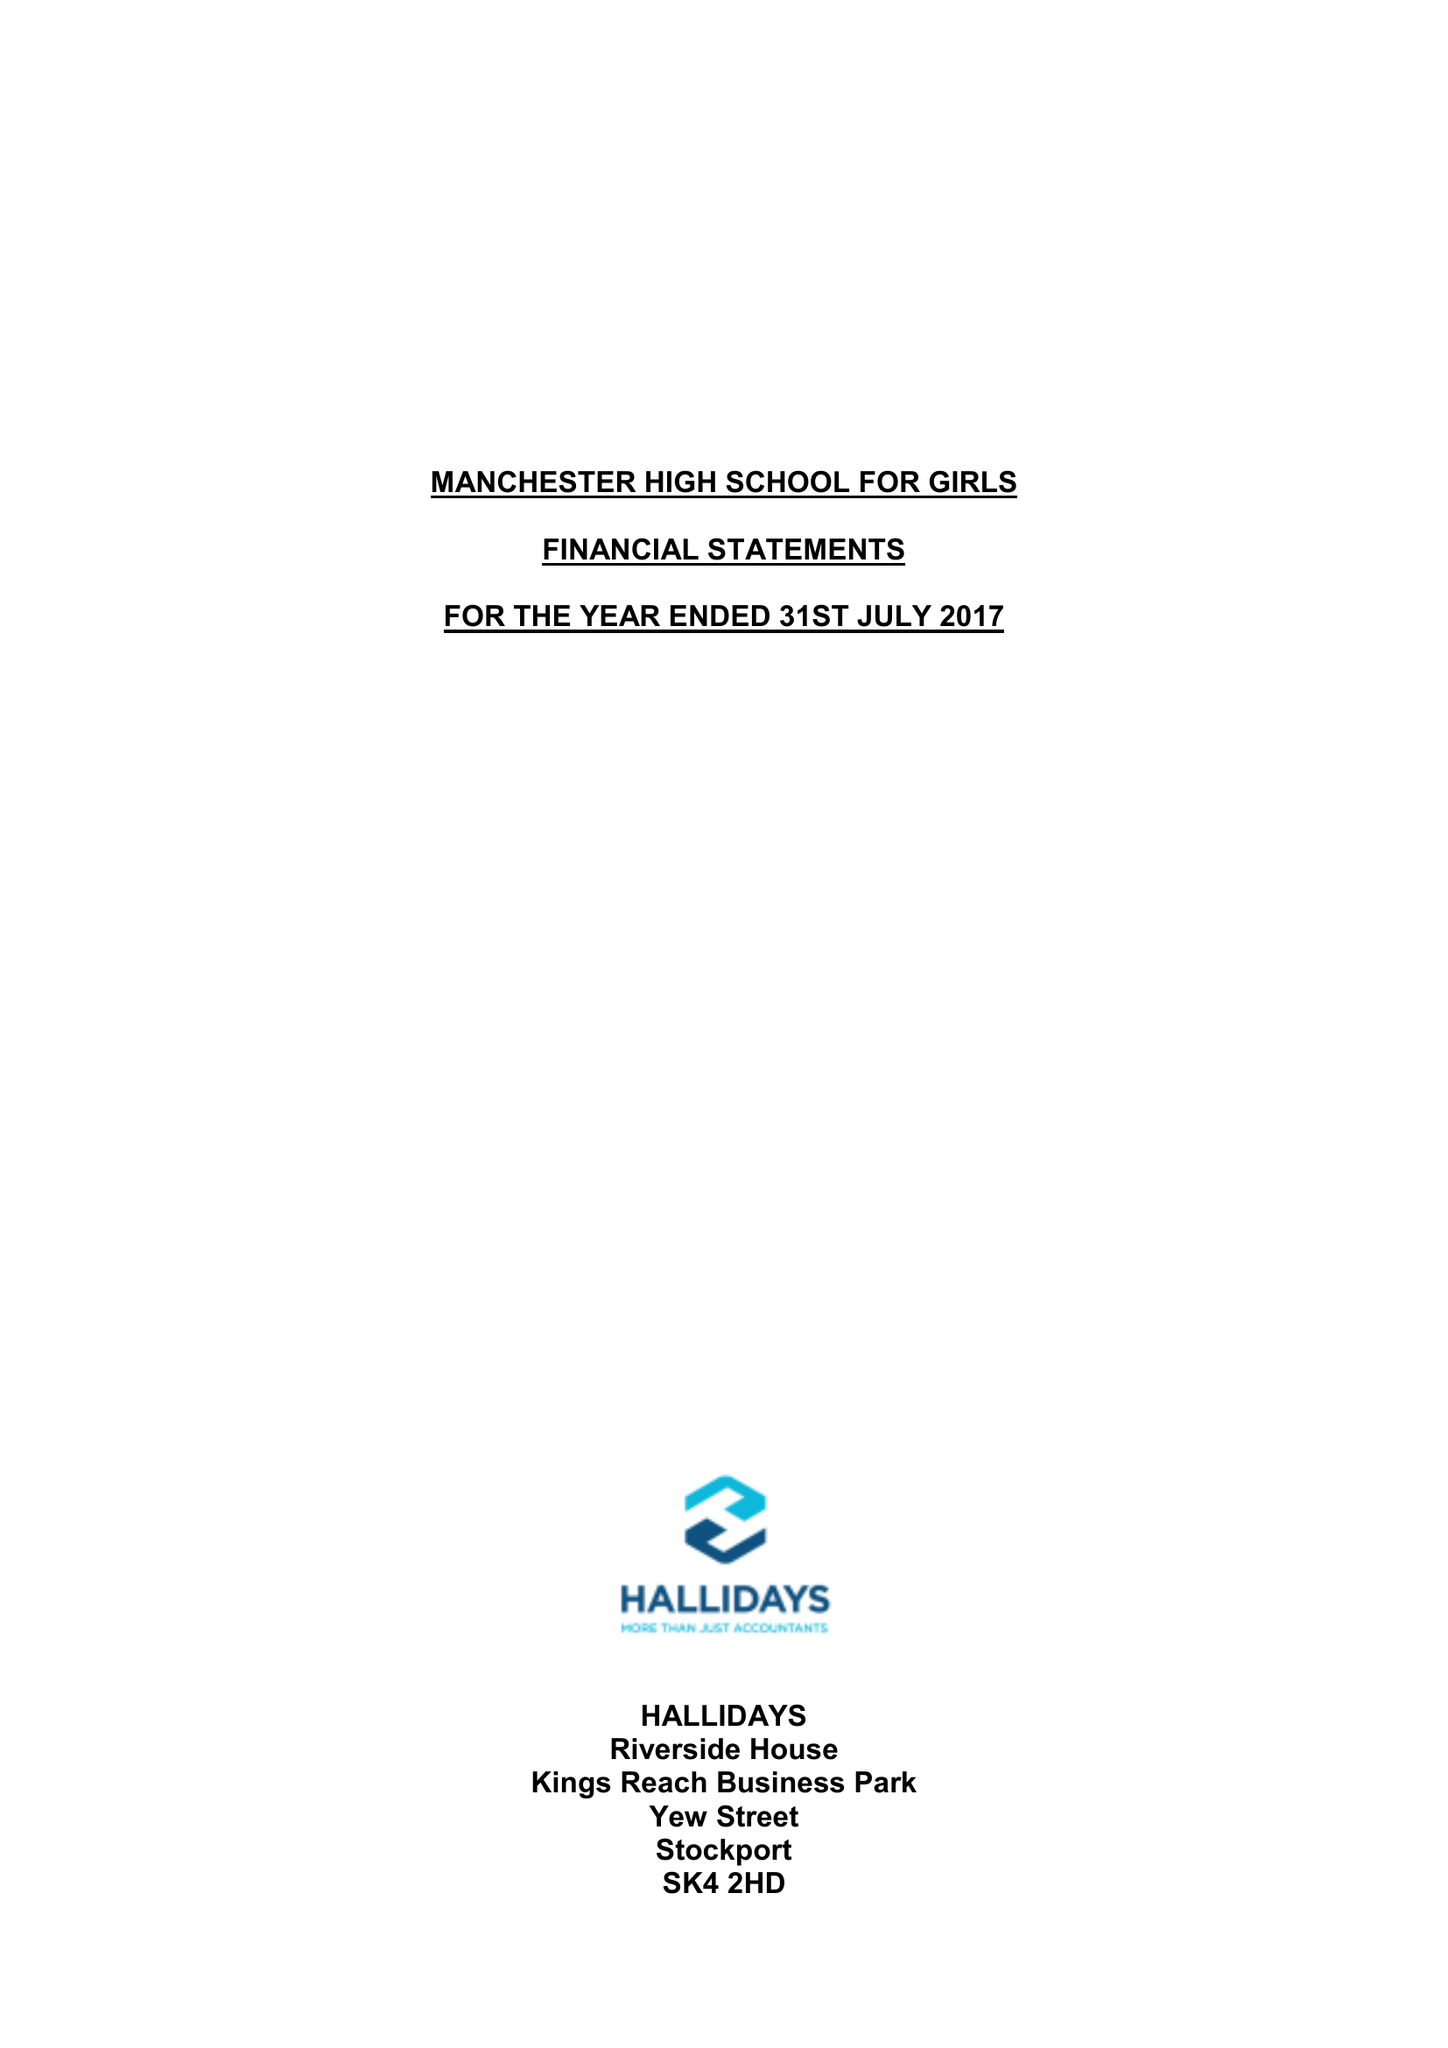What is the value for the address__street_line?
Answer the question using a single word or phrase. GRANGETHORPE ROAD 